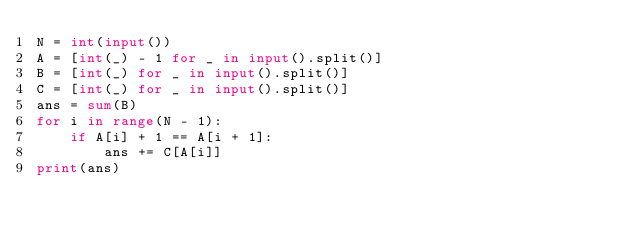Convert code to text. <code><loc_0><loc_0><loc_500><loc_500><_Python_>N = int(input())
A = [int(_) - 1 for _ in input().split()]
B = [int(_) for _ in input().split()]
C = [int(_) for _ in input().split()]
ans = sum(B)
for i in range(N - 1):
    if A[i] + 1 == A[i + 1]:
        ans += C[A[i]]
print(ans)</code> 